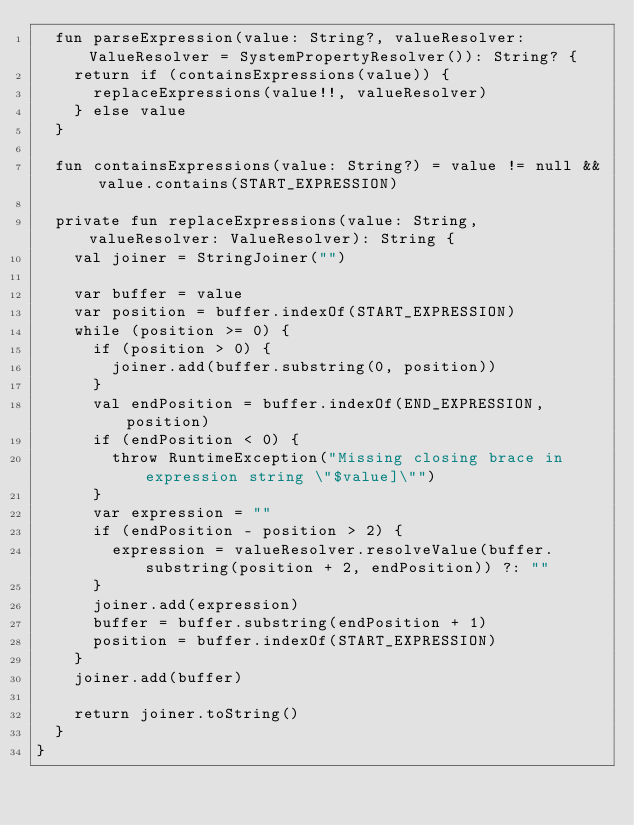Convert code to text. <code><loc_0><loc_0><loc_500><loc_500><_Kotlin_>  fun parseExpression(value: String?, valueResolver: ValueResolver = SystemPropertyResolver()): String? {
    return if (containsExpressions(value)) {
      replaceExpressions(value!!, valueResolver)
    } else value
  }

  fun containsExpressions(value: String?) = value != null && value.contains(START_EXPRESSION)

  private fun replaceExpressions(value: String, valueResolver: ValueResolver): String {
    val joiner = StringJoiner("")

    var buffer = value
    var position = buffer.indexOf(START_EXPRESSION)
    while (position >= 0) {
      if (position > 0) {
        joiner.add(buffer.substring(0, position))
      }
      val endPosition = buffer.indexOf(END_EXPRESSION, position)
      if (endPosition < 0) {
        throw RuntimeException("Missing closing brace in expression string \"$value]\"")
      }
      var expression = ""
      if (endPosition - position > 2) {
        expression = valueResolver.resolveValue(buffer.substring(position + 2, endPosition)) ?: ""
      }
      joiner.add(expression)
      buffer = buffer.substring(endPosition + 1)
      position = buffer.indexOf(START_EXPRESSION)
    }
    joiner.add(buffer)

    return joiner.toString()
  }
}
</code> 